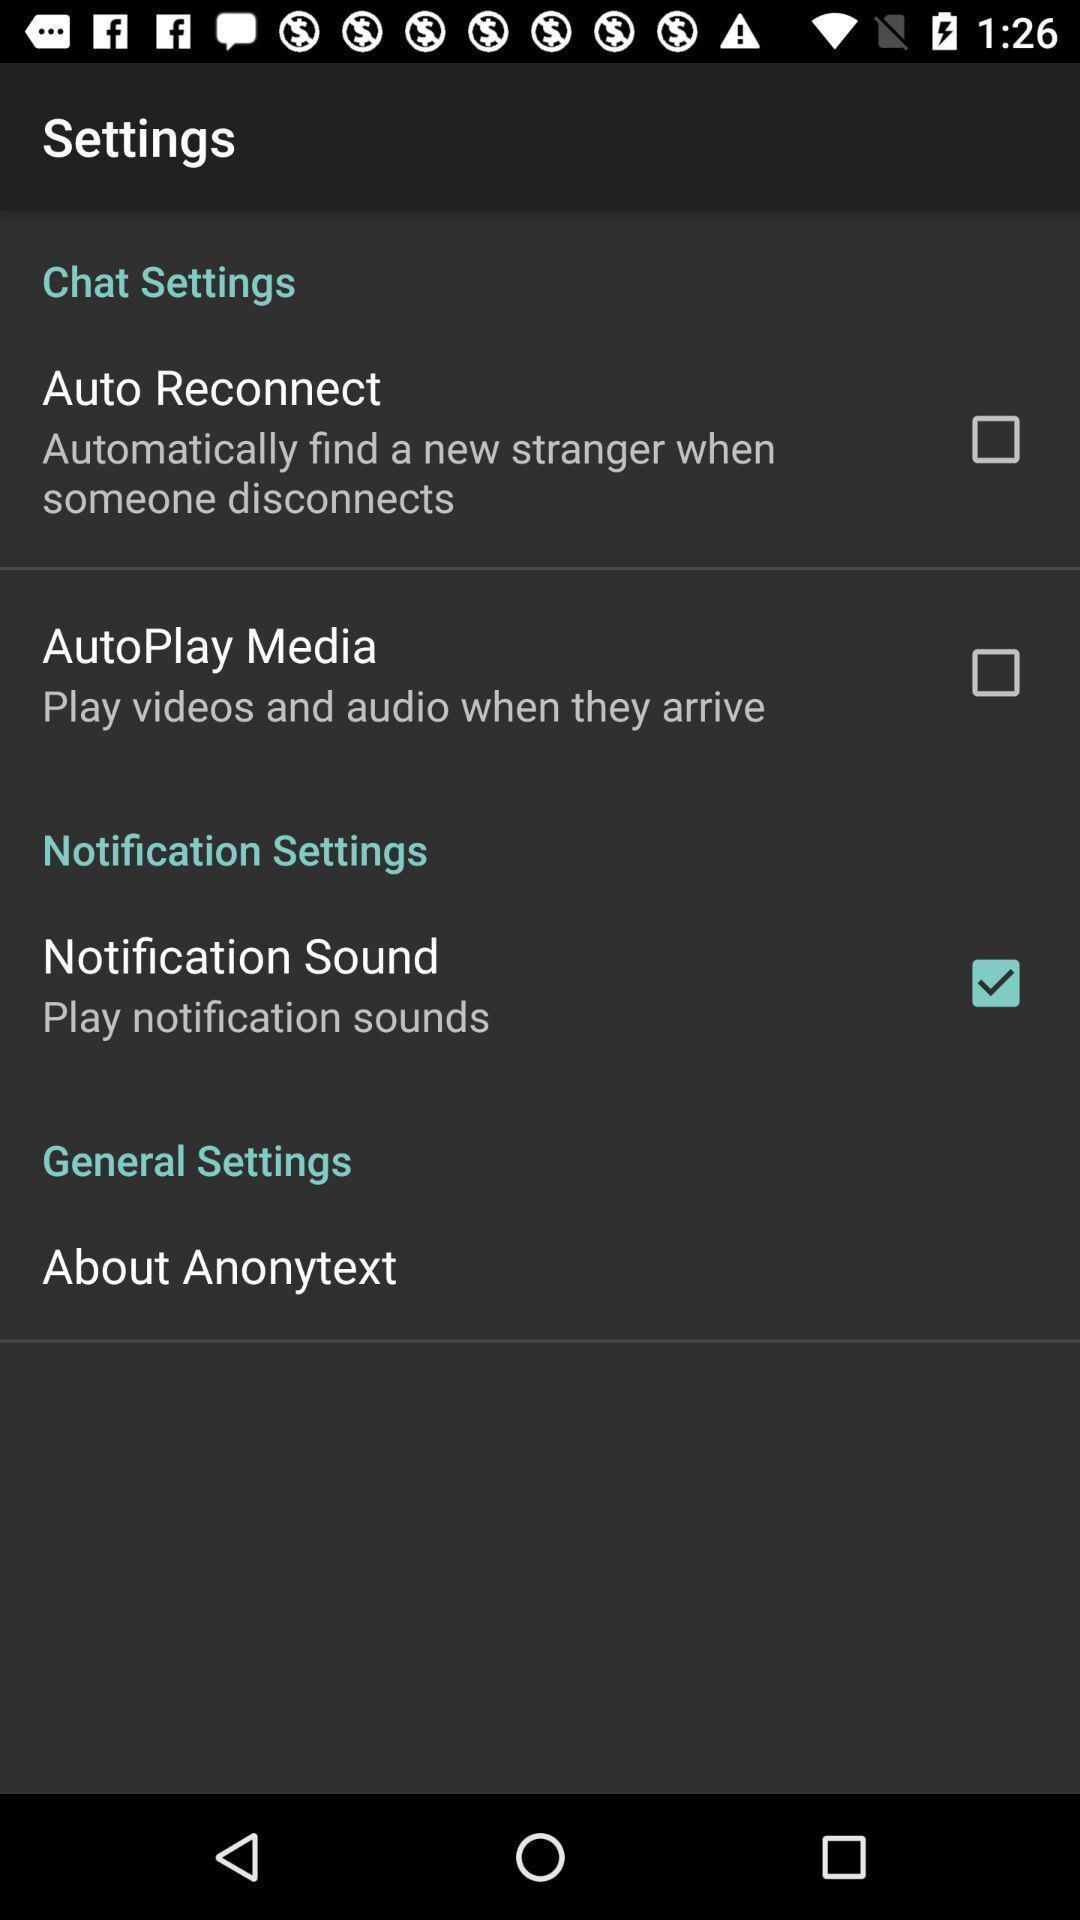Describe the visual elements of this screenshot. Settings page displaying different options an of application. 